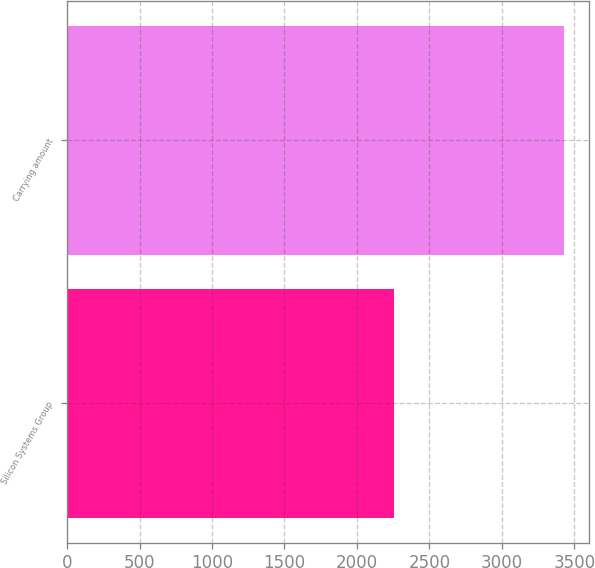Convert chart to OTSL. <chart><loc_0><loc_0><loc_500><loc_500><bar_chart><fcel>Silicon Systems Group<fcel>Carrying amount<nl><fcel>2254<fcel>3431<nl></chart> 